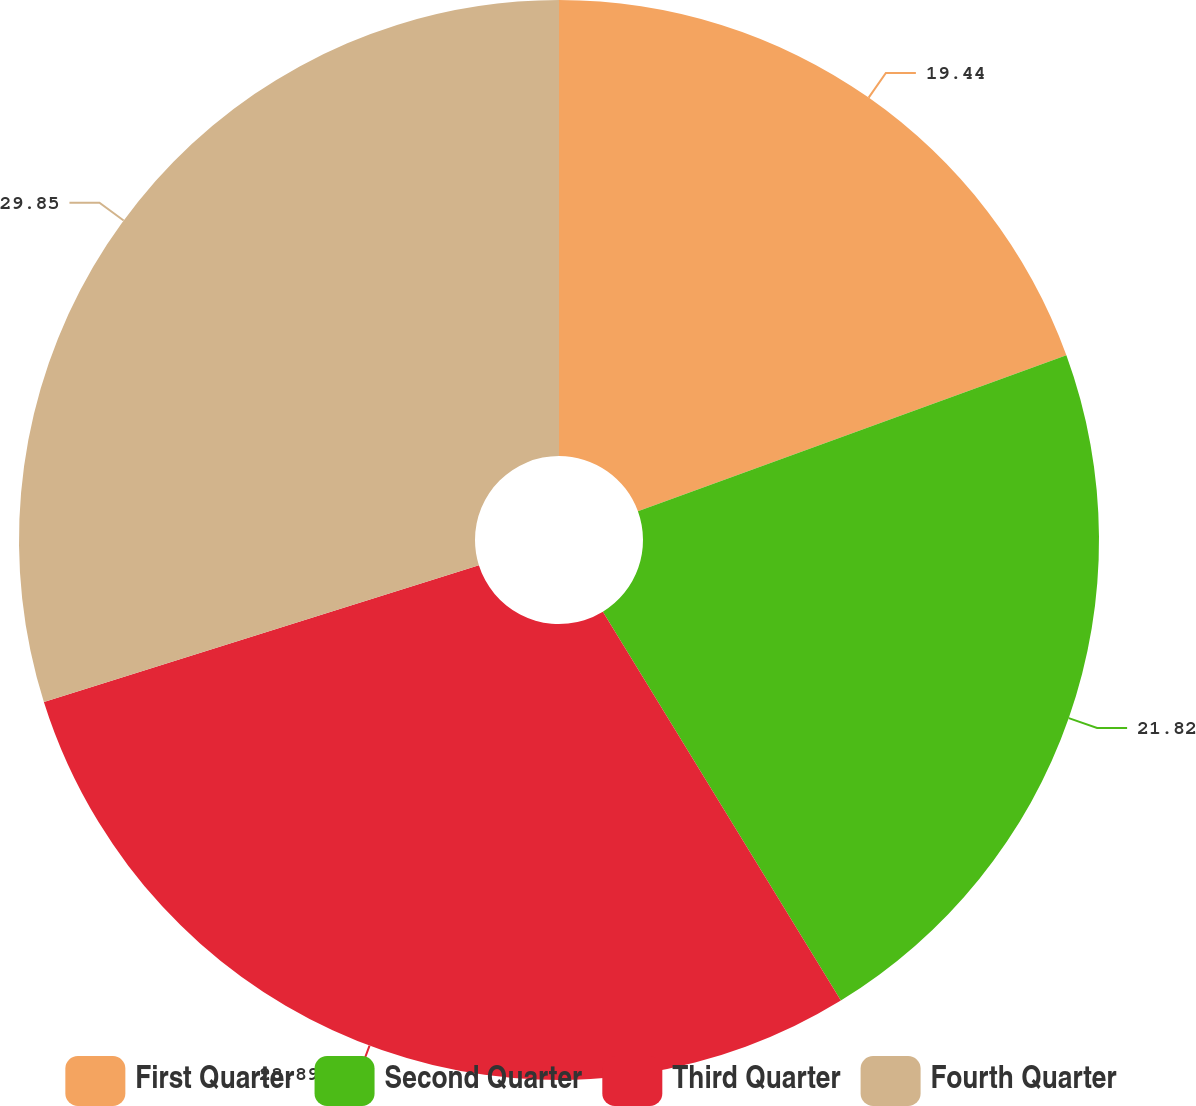Convert chart to OTSL. <chart><loc_0><loc_0><loc_500><loc_500><pie_chart><fcel>First Quarter<fcel>Second Quarter<fcel>Third Quarter<fcel>Fourth Quarter<nl><fcel>19.44%<fcel>21.82%<fcel>28.89%<fcel>29.85%<nl></chart> 